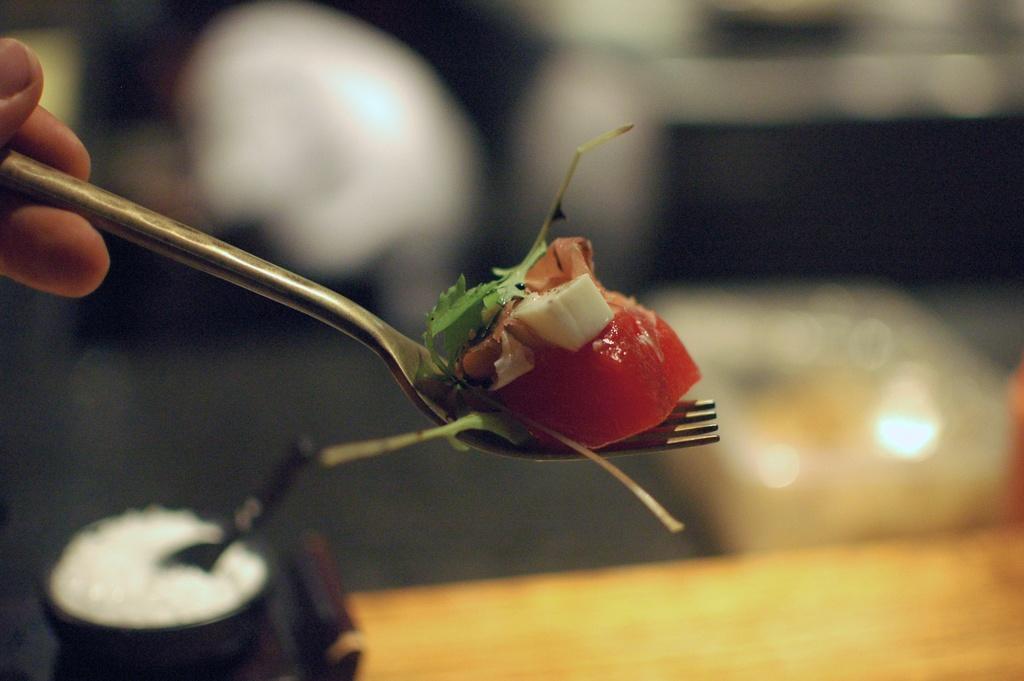Could you give a brief overview of what you see in this image? In this image we can see the hand of a person holding a fork containing some food on it. On the backside we can see a table and a bowl with a spoon in it. 